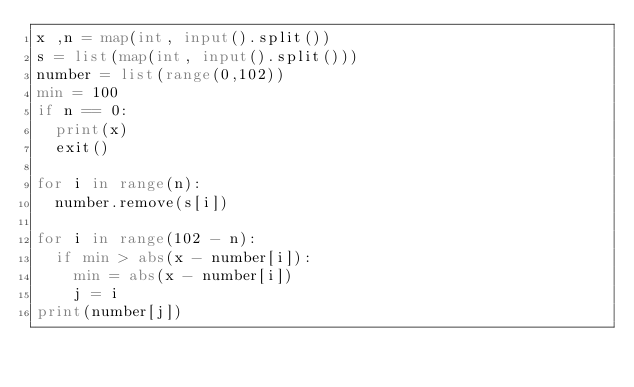<code> <loc_0><loc_0><loc_500><loc_500><_Python_>x ,n = map(int, input().split())
s = list(map(int, input().split()))
number = list(range(0,102))
min = 100
if n == 0:
  print(x)
  exit()
  
for i in range(n):
  number.remove(s[i])

for i in range(102 - n):
  if min > abs(x - number[i]):
    min = abs(x - number[i])
    j = i
print(number[j])
</code> 